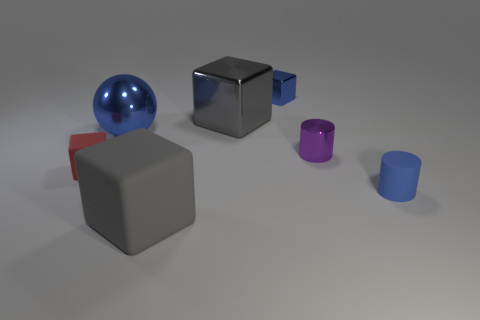Subtract all tiny rubber cubes. How many cubes are left? 3 Subtract all red blocks. How many blocks are left? 3 Add 2 matte cylinders. How many objects exist? 9 Subtract all cylinders. How many objects are left? 5 Subtract all gray cubes. Subtract all cyan spheres. How many cubes are left? 2 Subtract all cyan blocks. How many green cylinders are left? 0 Subtract all small rubber cylinders. Subtract all big metal cubes. How many objects are left? 5 Add 1 shiny blocks. How many shiny blocks are left? 3 Add 6 big gray things. How many big gray things exist? 8 Subtract 0 brown cylinders. How many objects are left? 7 